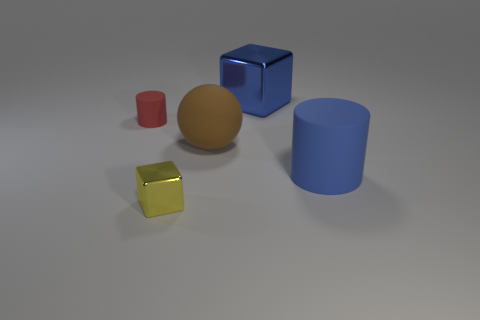How many spheres have the same material as the brown thing?
Provide a succinct answer. 0. How many large metal objects are behind the rubber thing on the right side of the large cube?
Ensure brevity in your answer.  1. What shape is the metal object behind the small object that is left of the block that is in front of the large matte sphere?
Ensure brevity in your answer.  Cube. There is a shiny thing that is the same color as the big rubber cylinder; what is its size?
Make the answer very short. Large. How many objects are matte objects or large metal spheres?
Make the answer very short. 3. There is another object that is the same size as the red thing; what is its color?
Ensure brevity in your answer.  Yellow. Do the red matte thing and the blue rubber thing to the right of the small yellow metallic block have the same shape?
Offer a very short reply. Yes. What number of objects are large blue cylinders that are right of the big blue metallic object or blue objects that are in front of the small red cylinder?
Give a very brief answer. 1. What shape is the large matte object that is the same color as the large metallic thing?
Your response must be concise. Cylinder. The big brown rubber object that is on the right side of the tiny yellow cube has what shape?
Your answer should be compact. Sphere. 